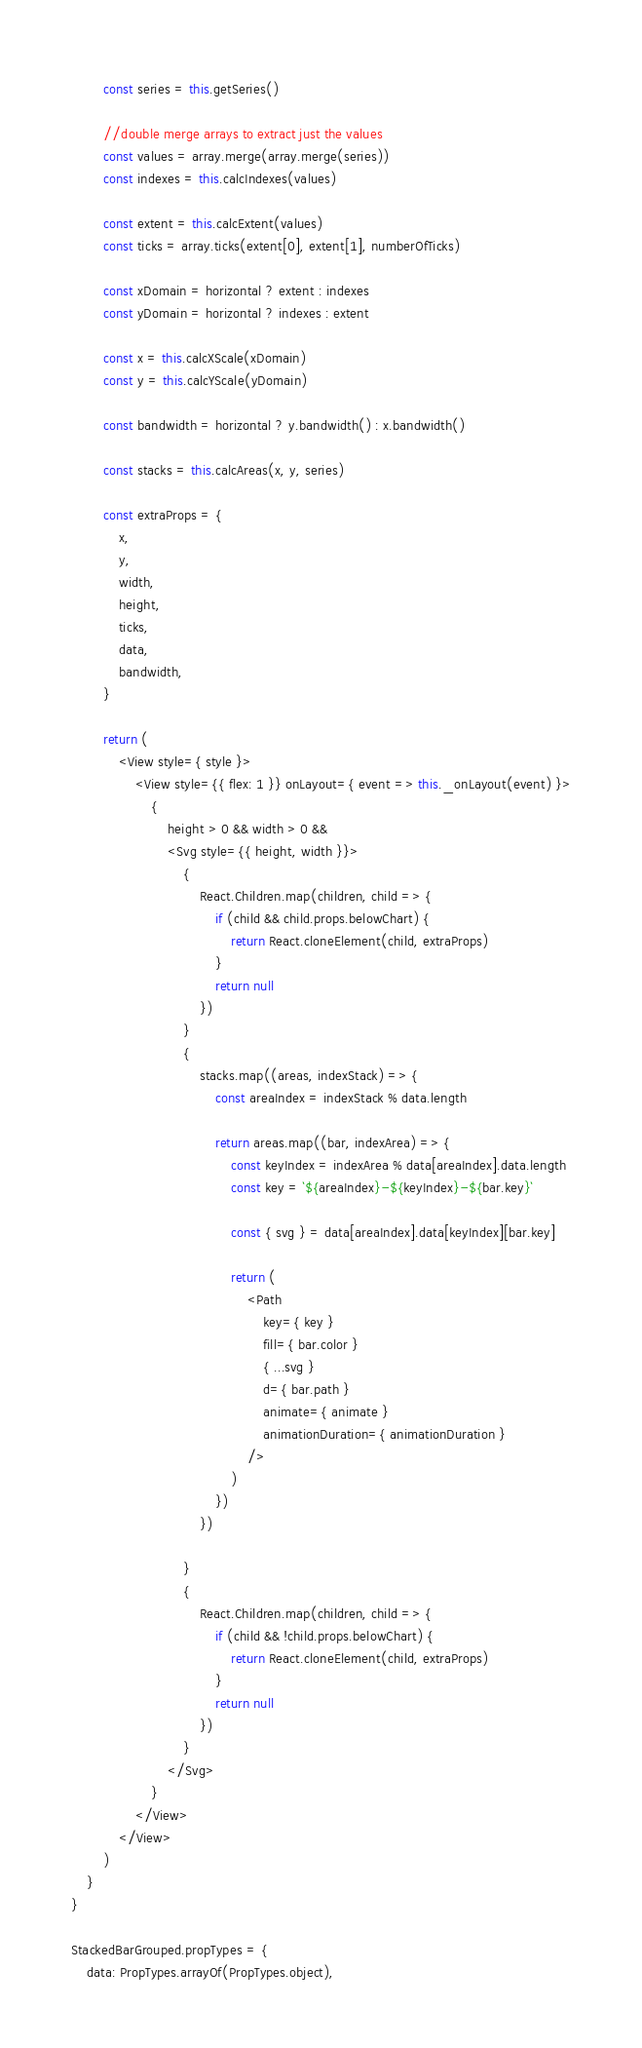Convert code to text. <code><loc_0><loc_0><loc_500><loc_500><_JavaScript_>        const series = this.getSeries()

        //double merge arrays to extract just the values
        const values = array.merge(array.merge(series))
        const indexes = this.calcIndexes(values)

        const extent = this.calcExtent(values)
        const ticks = array.ticks(extent[0], extent[1], numberOfTicks)

        const xDomain = horizontal ? extent : indexes
        const yDomain = horizontal ? indexes : extent

        const x = this.calcXScale(xDomain)
        const y = this.calcYScale(yDomain)

        const bandwidth = horizontal ? y.bandwidth() : x.bandwidth()

        const stacks = this.calcAreas(x, y, series)

        const extraProps = {
            x,
            y,
            width,
            height,
            ticks,
            data,
            bandwidth,
        }

        return (
            <View style={ style }>
                <View style={{ flex: 1 }} onLayout={ event => this._onLayout(event) }>
                    {
                        height > 0 && width > 0 &&
                        <Svg style={{ height, width }}>
                            {
                                React.Children.map(children, child => {
                                    if (child && child.props.belowChart) {
                                        return React.cloneElement(child, extraProps)
                                    }
                                    return null
                                })
                            }
                            {
                                stacks.map((areas, indexStack) => {
                                    const areaIndex = indexStack % data.length

                                    return areas.map((bar, indexArea) => {
                                        const keyIndex = indexArea % data[areaIndex].data.length
                                        const key = `${areaIndex}-${keyIndex}-${bar.key}`

                                        const { svg } = data[areaIndex].data[keyIndex][bar.key]

                                        return (
                                            <Path
                                                key={ key }
                                                fill={ bar.color }
                                                { ...svg }
                                                d={ bar.path }
                                                animate={ animate }
                                                animationDuration={ animationDuration }
                                            />
                                        )
                                    })
                                })

                            }
                            {
                                React.Children.map(children, child => {
                                    if (child && !child.props.belowChart) {
                                        return React.cloneElement(child, extraProps)
                                    }
                                    return null
                                })
                            }
                        </Svg>
                    }
                </View>
            </View>
        )
    }
}

StackedBarGrouped.propTypes = {
    data: PropTypes.arrayOf(PropTypes.object),</code> 